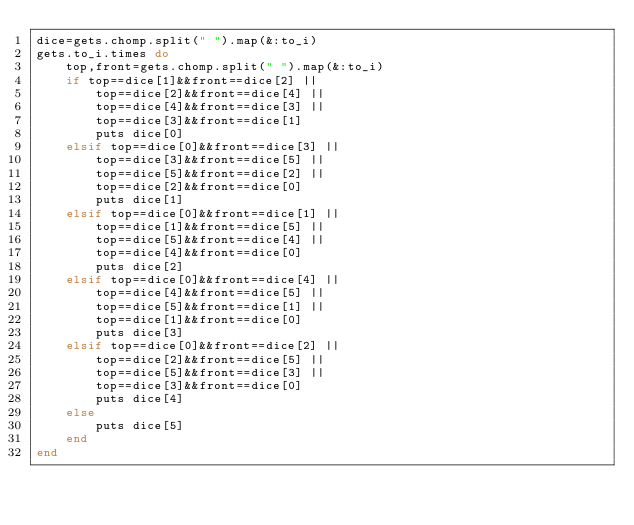Convert code to text. <code><loc_0><loc_0><loc_500><loc_500><_Ruby_>dice=gets.chomp.split(" ").map(&:to_i)
gets.to_i.times do
    top,front=gets.chomp.split(" ").map(&:to_i)
    if top==dice[1]&&front==dice[2] ||
        top==dice[2]&&front==dice[4] ||
        top==dice[4]&&front==dice[3] ||
        top==dice[3]&&front==dice[1]
        puts dice[0]
    elsif top==dice[0]&&front==dice[3] ||
        top==dice[3]&&front==dice[5] ||
        top==dice[5]&&front==dice[2] ||
        top==dice[2]&&front==dice[0]
        puts dice[1]
    elsif top==dice[0]&&front==dice[1] ||
        top==dice[1]&&front==dice[5] ||
        top==dice[5]&&front==dice[4] ||
        top==dice[4]&&front==dice[0]
        puts dice[2]
    elsif top==dice[0]&&front==dice[4] ||
        top==dice[4]&&front==dice[5] ||
        top==dice[5]&&front==dice[1] ||
        top==dice[1]&&front==dice[0]
        puts dice[3]
    elsif top==dice[0]&&front==dice[2] ||
        top==dice[2]&&front==dice[5] ||
        top==dice[5]&&front==dice[3] ||
        top==dice[3]&&front==dice[0]
        puts dice[4]
    else
        puts dice[5]
    end
end
</code> 